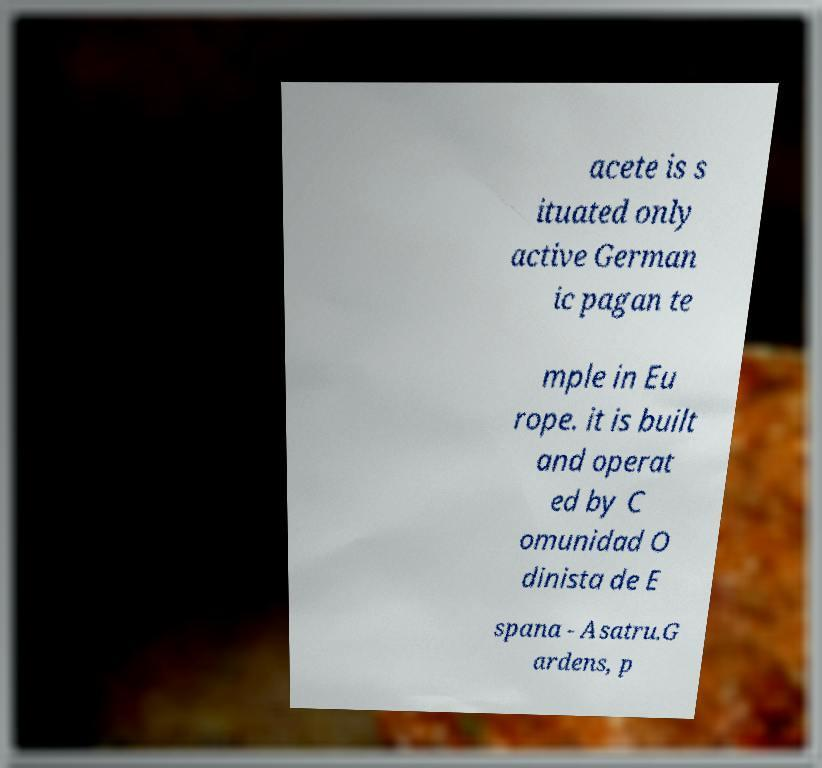Please identify and transcribe the text found in this image. acete is s ituated only active German ic pagan te mple in Eu rope. it is built and operat ed by C omunidad O dinista de E spana - Asatru.G ardens, p 